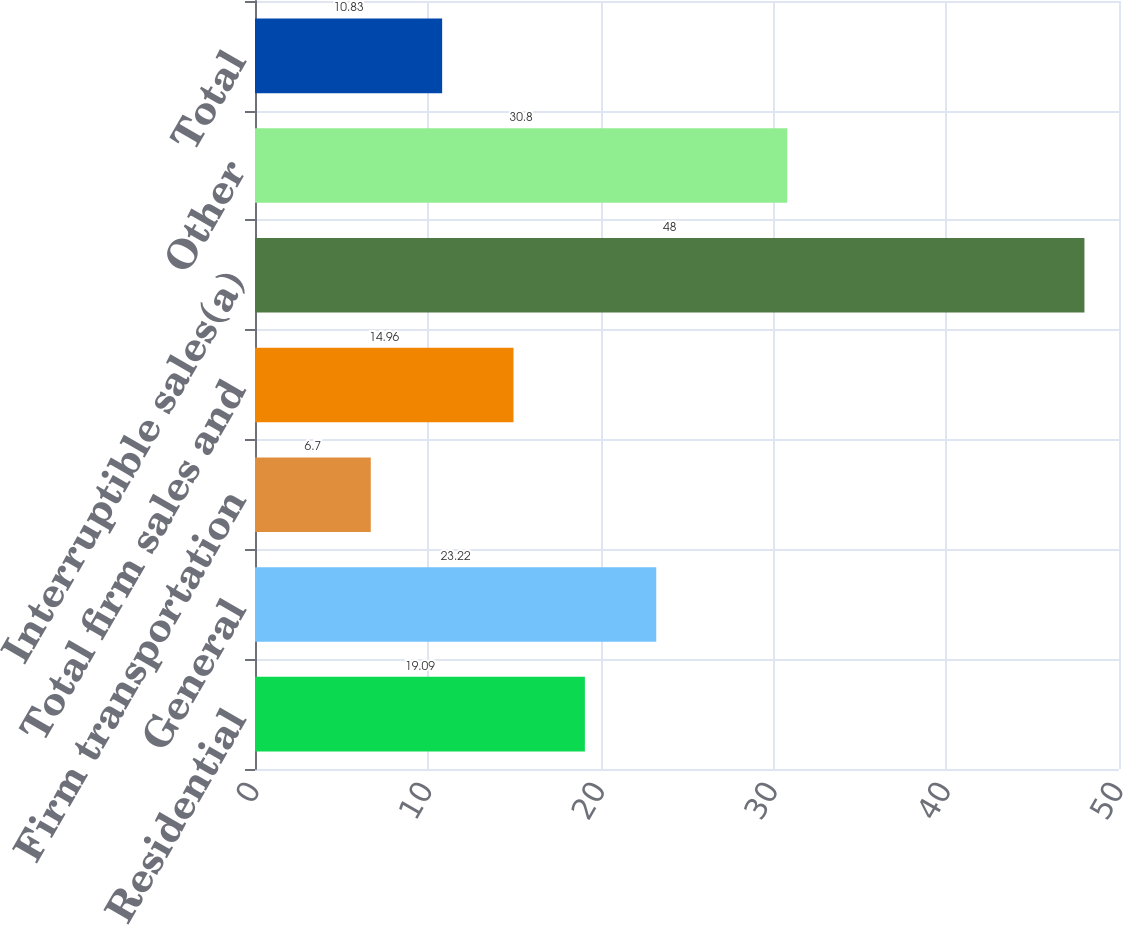Convert chart to OTSL. <chart><loc_0><loc_0><loc_500><loc_500><bar_chart><fcel>Residential<fcel>General<fcel>Firm transportation<fcel>Total firm sales and<fcel>Interruptible sales(a)<fcel>Other<fcel>Total<nl><fcel>19.09<fcel>23.22<fcel>6.7<fcel>14.96<fcel>48<fcel>30.8<fcel>10.83<nl></chart> 